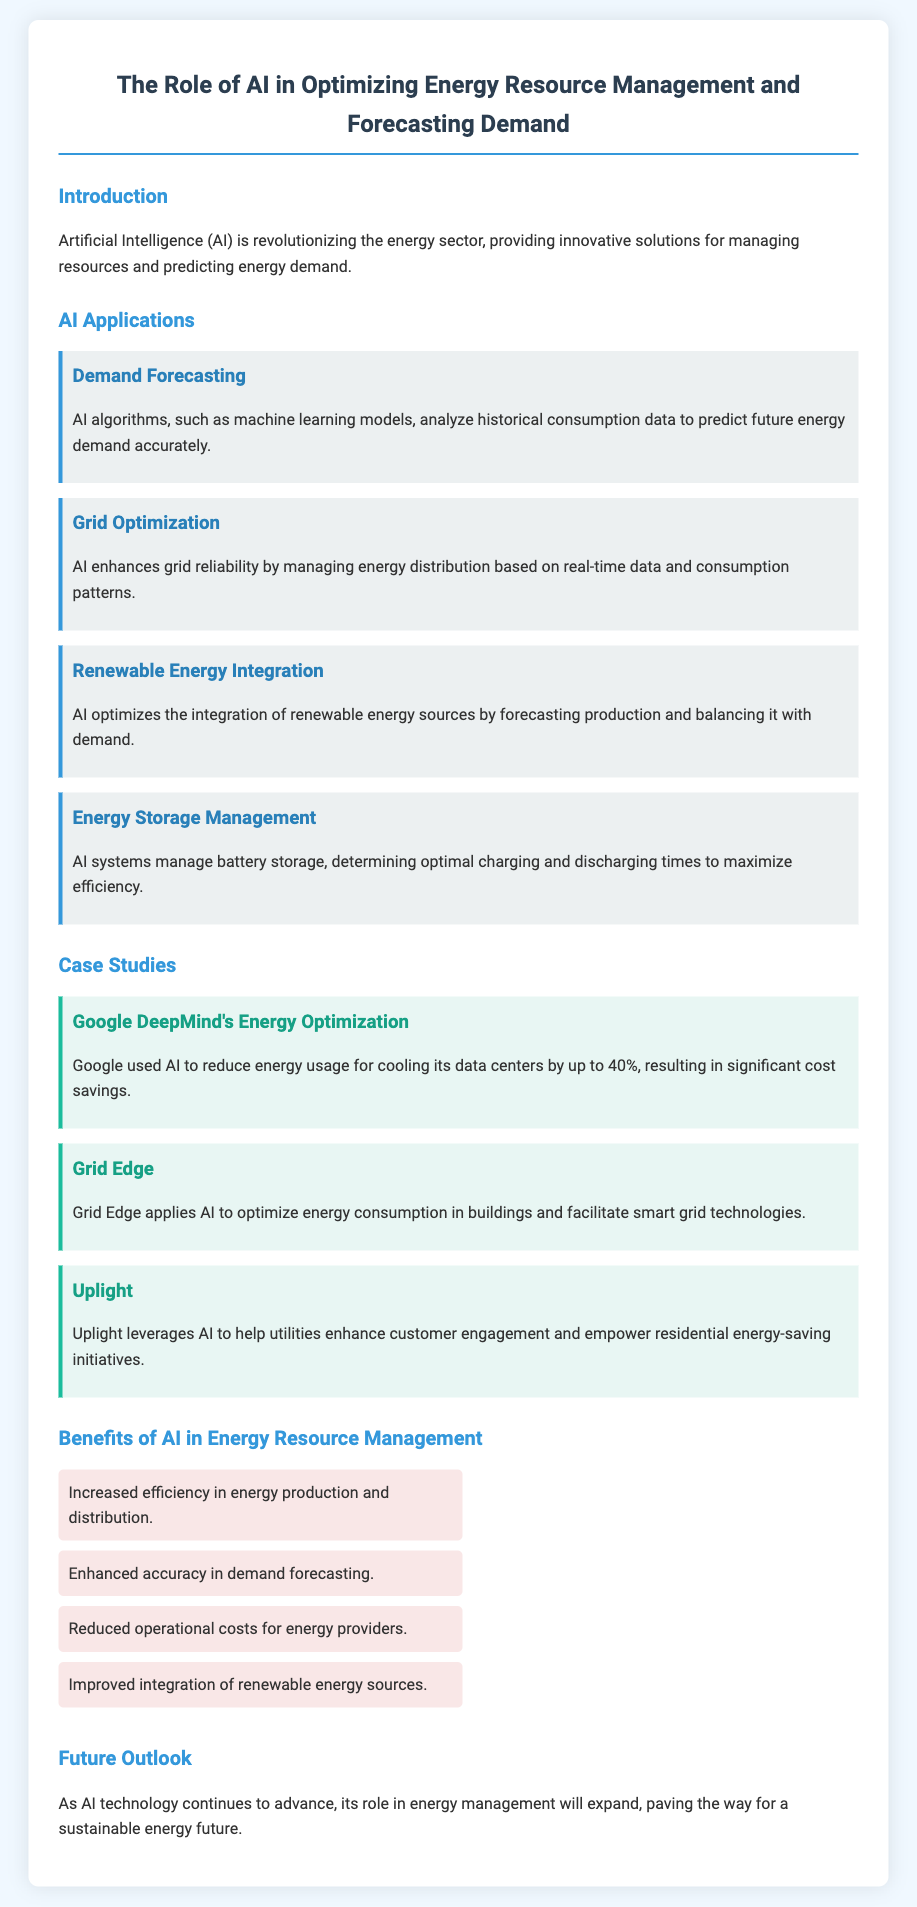what is the title of the document? The title of the document is explicitly mentioned in the header section of the HTML code as the main heading.
Answer: The Role of AI in Optimizing Energy Resource Management and Forecasting Demand what is one application of AI mentioned in the document? The document lists several applications of AI under the section titled "AI Applications."
Answer: Demand Forecasting how much energy usage did Google reduce for cooling its data centers? The case study about Google DeepMind highlights the percentage of energy usage reduction.
Answer: 40% what benefit of AI is related to operational costs? The section on benefits lists advantages that AI provides to energy providers, including cost-related benefits.
Answer: Reduced operational costs for energy providers which company leverages AI to enhance customer engagement? The document mentions various case studies, including one focused on customer engagement and energy-saving initiatives.
Answer: Uplight what is one advantage of AI in demand forecasting? The "Benefits of AI in Energy Resource Management" section highlights specific advantages that AI provides, including accuracy-related benefits.
Answer: Enhanced accuracy in demand forecasting which application of AI helps in managing battery storage? The document specifies various AI applications, including one focused on a certain aspect of energy management.
Answer: Energy Storage Management what is the primary focus of the document? The main introduction of the document outlines the central theme, which is related to the role of AI.
Answer: The energy sector 